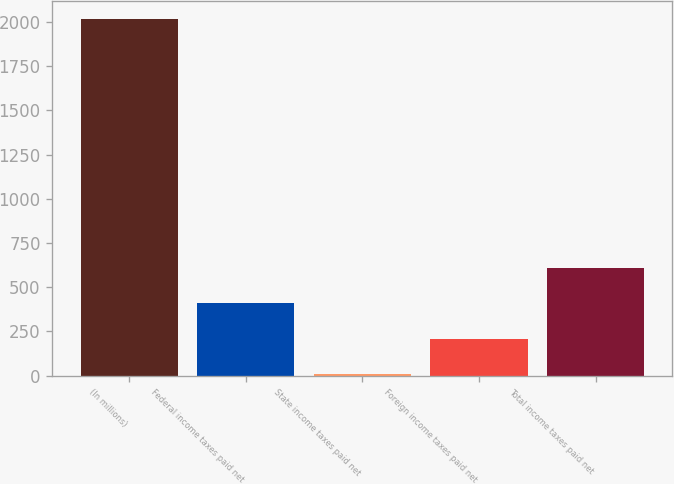Convert chart. <chart><loc_0><loc_0><loc_500><loc_500><bar_chart><fcel>(In millions)<fcel>Federal income taxes paid net<fcel>State income taxes paid net<fcel>Foreign income taxes paid net<fcel>Total income taxes paid net<nl><fcel>2015<fcel>408.76<fcel>7.2<fcel>207.98<fcel>609.54<nl></chart> 